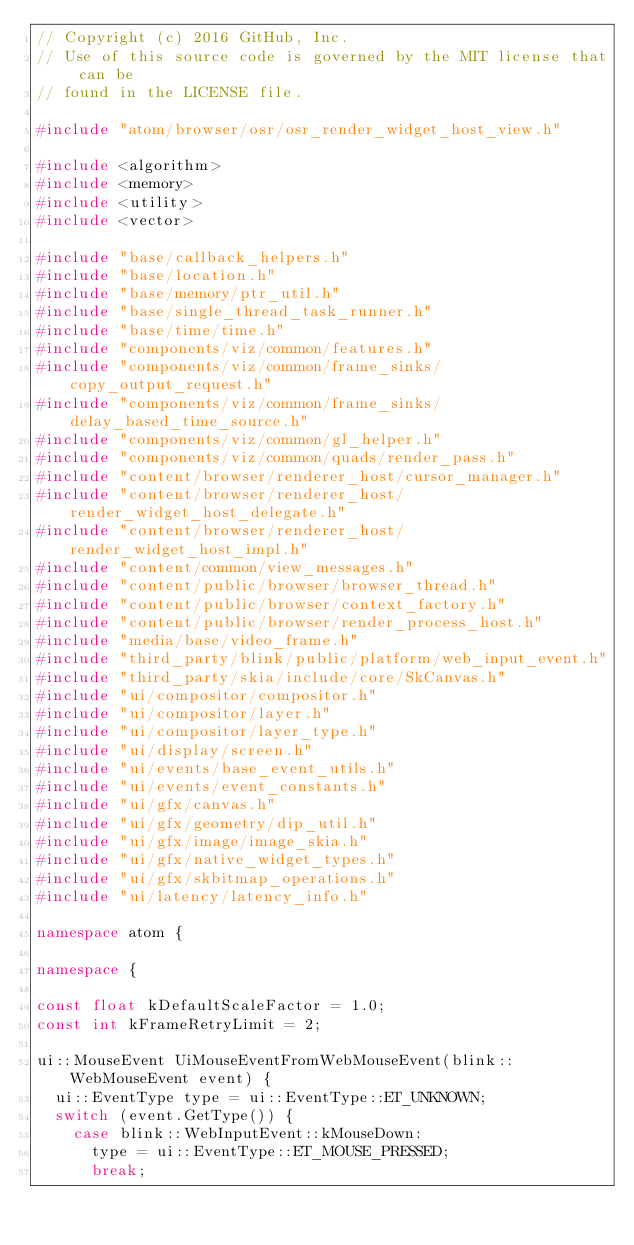Convert code to text. <code><loc_0><loc_0><loc_500><loc_500><_C++_>// Copyright (c) 2016 GitHub, Inc.
// Use of this source code is governed by the MIT license that can be
// found in the LICENSE file.

#include "atom/browser/osr/osr_render_widget_host_view.h"

#include <algorithm>
#include <memory>
#include <utility>
#include <vector>

#include "base/callback_helpers.h"
#include "base/location.h"
#include "base/memory/ptr_util.h"
#include "base/single_thread_task_runner.h"
#include "base/time/time.h"
#include "components/viz/common/features.h"
#include "components/viz/common/frame_sinks/copy_output_request.h"
#include "components/viz/common/frame_sinks/delay_based_time_source.h"
#include "components/viz/common/gl_helper.h"
#include "components/viz/common/quads/render_pass.h"
#include "content/browser/renderer_host/cursor_manager.h"
#include "content/browser/renderer_host/render_widget_host_delegate.h"
#include "content/browser/renderer_host/render_widget_host_impl.h"
#include "content/common/view_messages.h"
#include "content/public/browser/browser_thread.h"
#include "content/public/browser/context_factory.h"
#include "content/public/browser/render_process_host.h"
#include "media/base/video_frame.h"
#include "third_party/blink/public/platform/web_input_event.h"
#include "third_party/skia/include/core/SkCanvas.h"
#include "ui/compositor/compositor.h"
#include "ui/compositor/layer.h"
#include "ui/compositor/layer_type.h"
#include "ui/display/screen.h"
#include "ui/events/base_event_utils.h"
#include "ui/events/event_constants.h"
#include "ui/gfx/canvas.h"
#include "ui/gfx/geometry/dip_util.h"
#include "ui/gfx/image/image_skia.h"
#include "ui/gfx/native_widget_types.h"
#include "ui/gfx/skbitmap_operations.h"
#include "ui/latency/latency_info.h"

namespace atom {

namespace {

const float kDefaultScaleFactor = 1.0;
const int kFrameRetryLimit = 2;

ui::MouseEvent UiMouseEventFromWebMouseEvent(blink::WebMouseEvent event) {
  ui::EventType type = ui::EventType::ET_UNKNOWN;
  switch (event.GetType()) {
    case blink::WebInputEvent::kMouseDown:
      type = ui::EventType::ET_MOUSE_PRESSED;
      break;</code> 